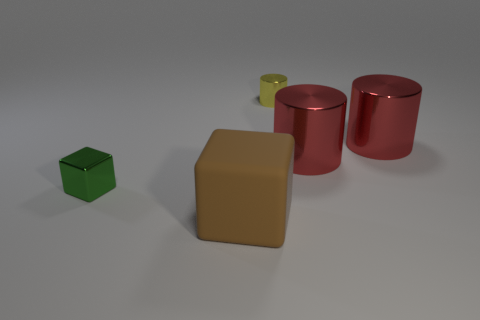Do the large rubber block and the small object right of the small green cube have the same color?
Offer a very short reply. No. There is a large cube in front of the tiny metal object to the left of the tiny shiny object that is behind the green thing; what is it made of?
Give a very brief answer. Rubber. There is a big object in front of the tiny metal cube; does it have the same shape as the yellow object?
Make the answer very short. No. There is a block on the right side of the green block; what is its material?
Provide a succinct answer. Rubber. How many rubber things are either cyan objects or small blocks?
Offer a very short reply. 0. Are there any brown matte things of the same size as the yellow thing?
Your answer should be compact. No. Is the number of large shiny objects that are behind the green block greater than the number of tiny cylinders?
Your answer should be compact. Yes. What number of tiny things are either brown matte objects or green metallic things?
Your response must be concise. 1. How many other brown objects have the same shape as the big rubber thing?
Offer a terse response. 0. There is a big thing that is in front of the small object that is left of the yellow metal thing; what is it made of?
Provide a short and direct response. Rubber. 